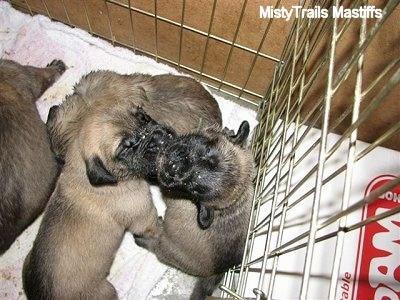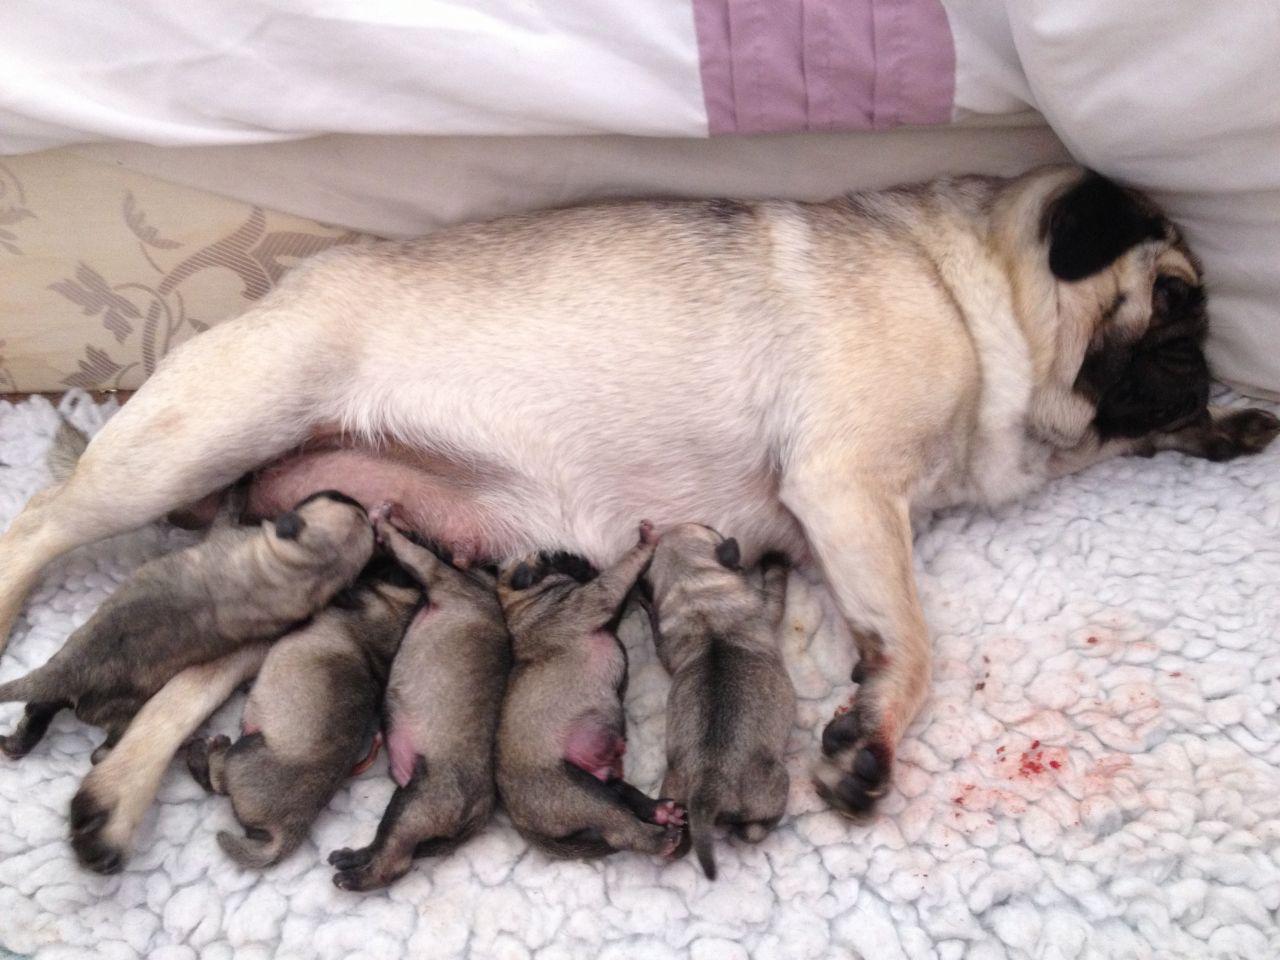The first image is the image on the left, the second image is the image on the right. Assess this claim about the two images: "There is an adult pug in each image.". Correct or not? Answer yes or no. No. The first image is the image on the left, the second image is the image on the right. Assess this claim about the two images: "There are exactly two dogs in one of the images.". Correct or not? Answer yes or no. No. 